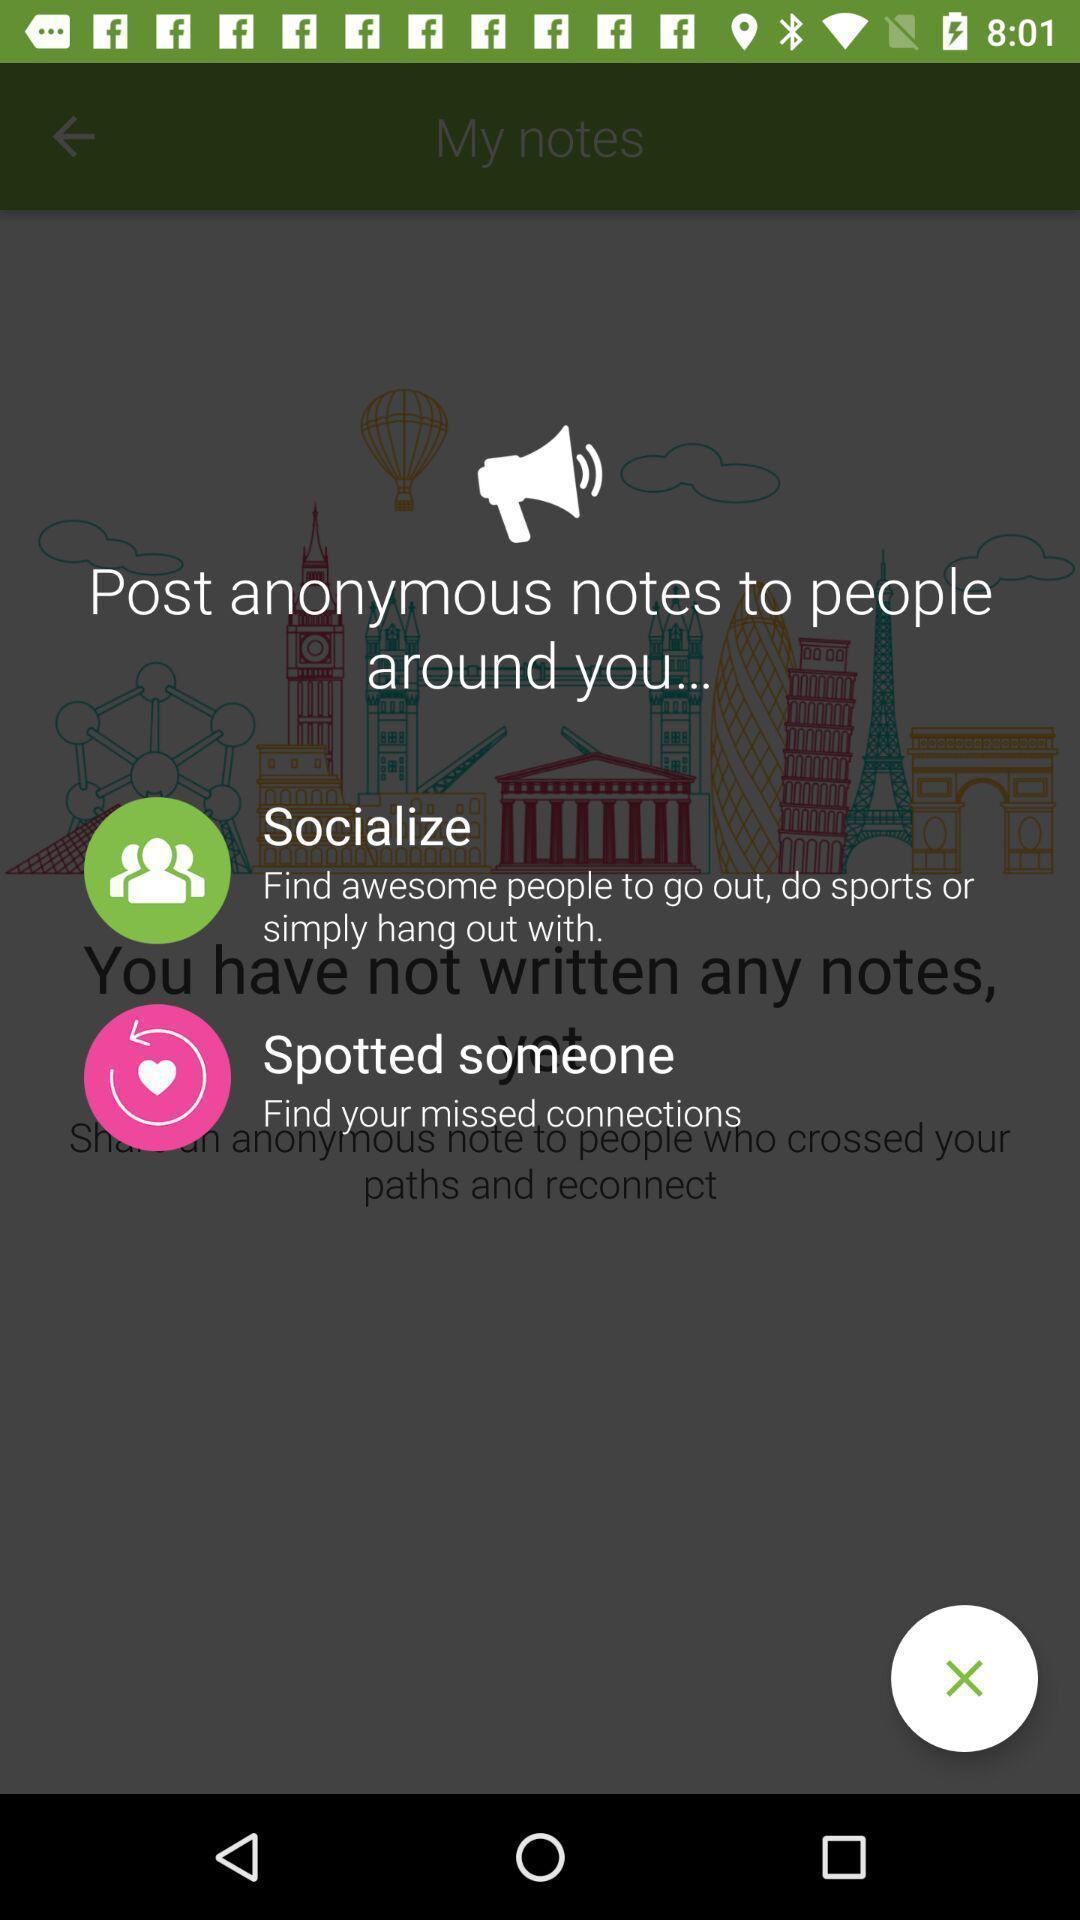Give me a summary of this screen capture. Window displaying an social app. 